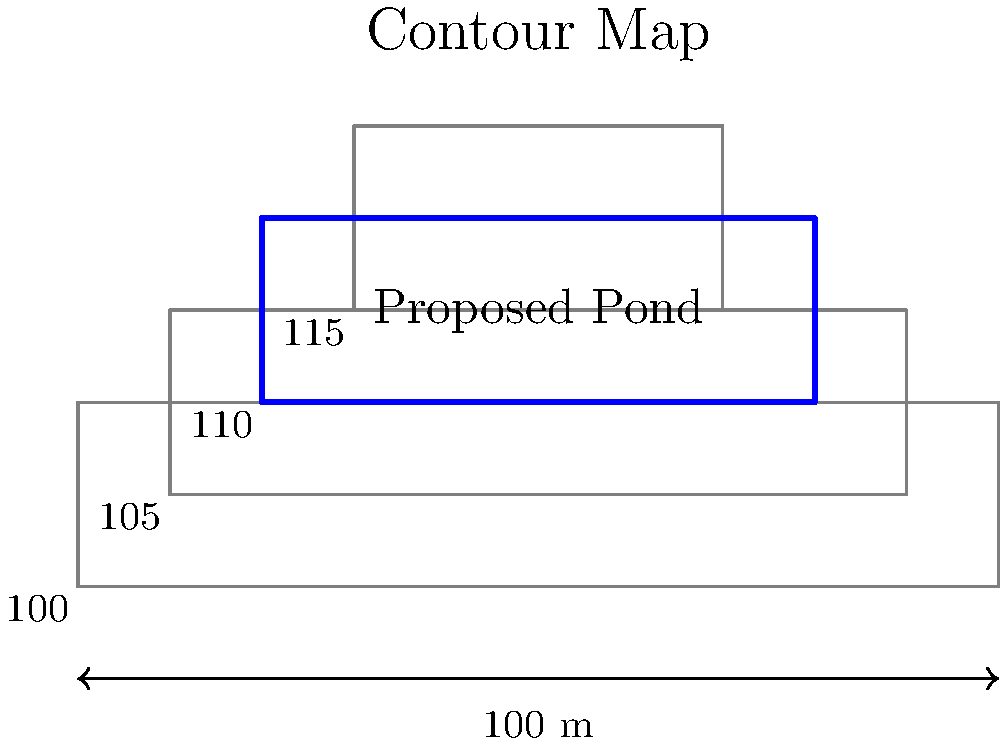As a community organizer planning a new disc golf course, you need to design a retention pond for stormwater management. Using the contour map provided, calculate the volume of the proposed rectangular retention pond with dimensions 60m x 20m. The pond's base elevation is at the 100m contour, and the top of the pond banks will be at the 105m contour. Assume the side slopes are vertical for this calculation. To calculate the volume of the retention pond, we'll follow these steps:

1. Identify the dimensions of the pond:
   Length = 60 m
   Width = 20 m
   Depth = 105 m - 100 m = 5 m

2. Calculate the volume using the formula for a rectangular prism:
   $V = l \times w \times d$
   where $V$ is volume, $l$ is length, $w$ is width, and $d$ is depth.

3. Substitute the values:
   $V = 60 \text{ m} \times 20 \text{ m} \times 5 \text{ m}$

4. Perform the calculation:
   $V = 6000 \text{ m}^3$

Therefore, the volume of the retention pond is 6000 cubic meters.

Note: In real-world scenarios, side slopes would typically be considered, which would slightly reduce the volume. However, for this calculation, we assumed vertical sides as specified in the question.
Answer: 6000 m³ 